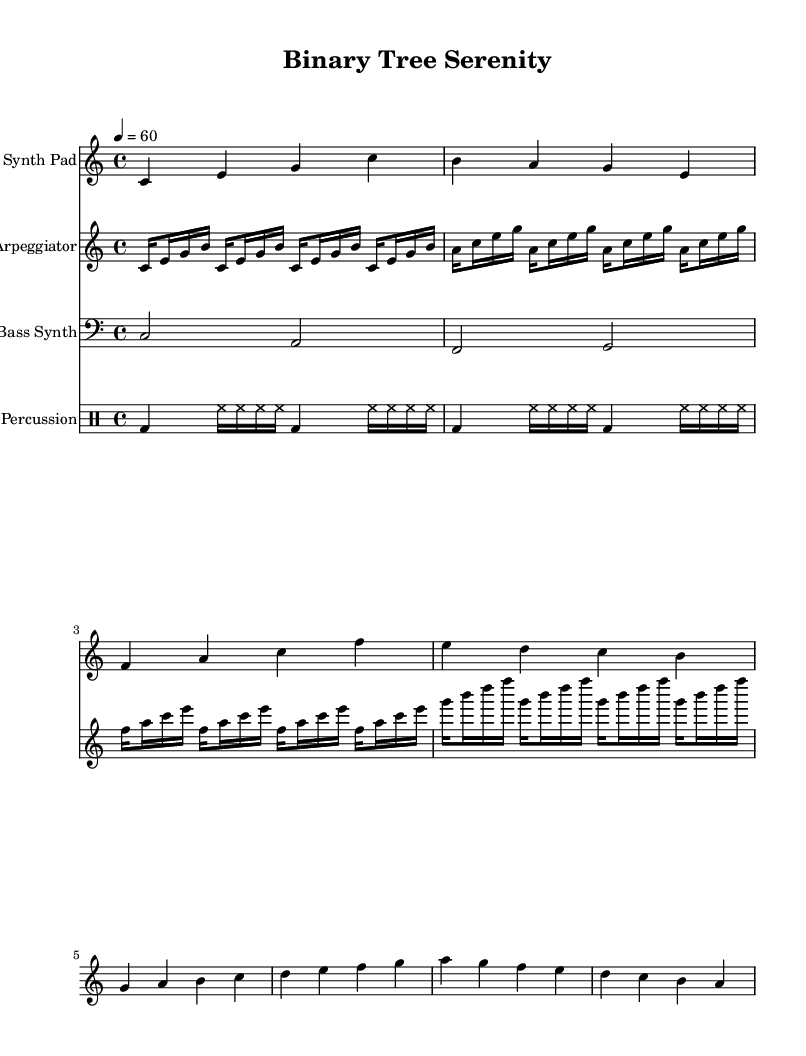What is the key signature of this music? The key signature is C major, which has no sharps or flats.
Answer: C major What is the time signature of this music? The time signature is indicated as 4/4, meaning there are four beats in each measure.
Answer: 4/4 What is the tempo of this piece? The tempo is specified as quarter note equals sixty beats per minute, which indicates the speed of the music.
Answer: 60 How many measures are in the melody section? The melody section consists of eight measures, which can be counted by analyzing the divided segments in the staff.
Answer: 8 What sequence of notes appears in the bass synth? The bass synth plays the sequence C, A, F, and G, as observed in the bass staff.
Answer: C, A, F, G What type of instrument is used for the arpeggiator part? The arpeggiator part is indicated to be played on a synthesizer, which is typical for ambient electronic music.
Answer: Arpeggiator How many beats does the percussion play before repeating the pattern? The percussion pattern plays for each measure of four beats before repeating, making it a total of four beats in each cycle.
Answer: 4 